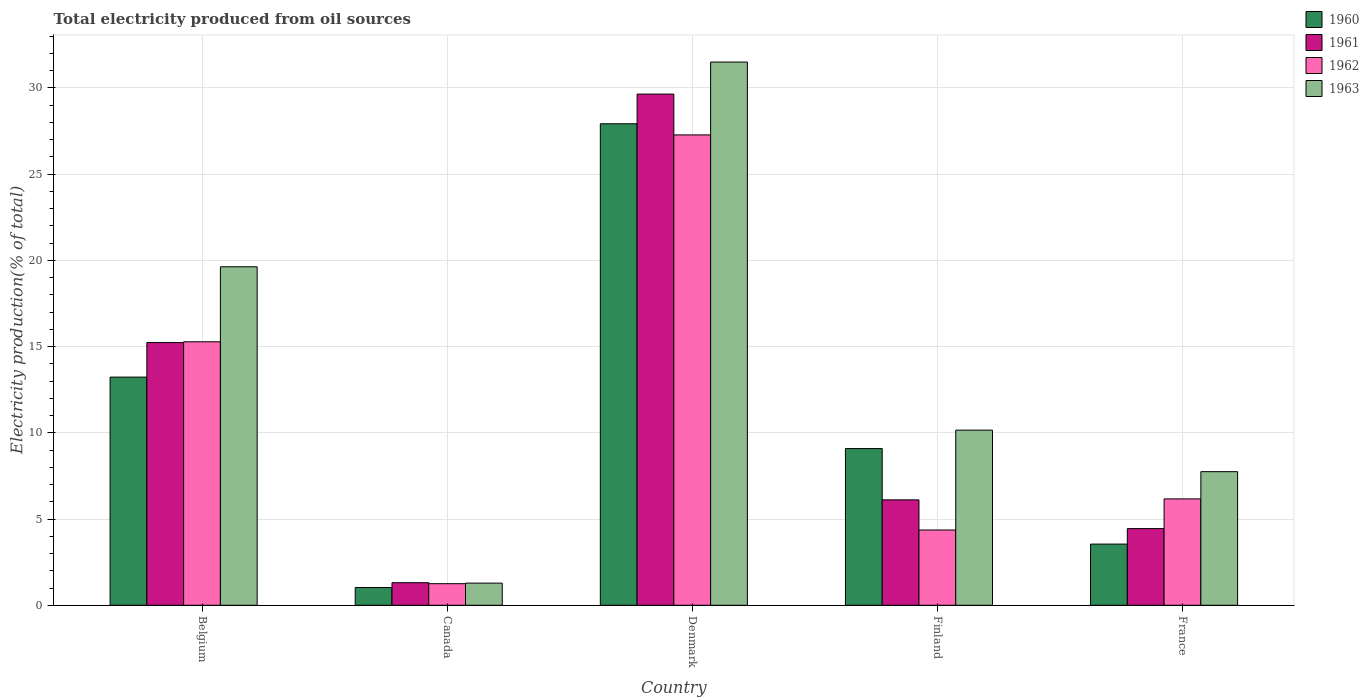How many bars are there on the 2nd tick from the left?
Offer a terse response. 4. How many bars are there on the 5th tick from the right?
Make the answer very short. 4. What is the label of the 2nd group of bars from the left?
Your answer should be compact. Canada. What is the total electricity produced in 1962 in Finland?
Your response must be concise. 4.36. Across all countries, what is the maximum total electricity produced in 1961?
Offer a very short reply. 29.65. Across all countries, what is the minimum total electricity produced in 1962?
Your response must be concise. 1.25. In which country was the total electricity produced in 1963 maximum?
Provide a short and direct response. Denmark. What is the total total electricity produced in 1963 in the graph?
Offer a very short reply. 70.32. What is the difference between the total electricity produced in 1962 in Belgium and that in France?
Offer a very short reply. 9.11. What is the difference between the total electricity produced in 1960 in France and the total electricity produced in 1962 in Finland?
Provide a short and direct response. -0.82. What is the average total electricity produced in 1963 per country?
Offer a terse response. 14.06. What is the difference between the total electricity produced of/in 1961 and total electricity produced of/in 1963 in Finland?
Your response must be concise. -4.04. In how many countries, is the total electricity produced in 1963 greater than 21 %?
Your response must be concise. 1. What is the ratio of the total electricity produced in 1963 in Denmark to that in Finland?
Offer a terse response. 3.1. Is the total electricity produced in 1961 in Canada less than that in Denmark?
Offer a very short reply. Yes. What is the difference between the highest and the second highest total electricity produced in 1961?
Offer a very short reply. 23.53. What is the difference between the highest and the lowest total electricity produced in 1960?
Give a very brief answer. 26.9. What does the 3rd bar from the left in Denmark represents?
Your answer should be very brief. 1962. What does the 3rd bar from the right in Canada represents?
Offer a very short reply. 1961. Are all the bars in the graph horizontal?
Make the answer very short. No. How many countries are there in the graph?
Keep it short and to the point. 5. What is the difference between two consecutive major ticks on the Y-axis?
Give a very brief answer. 5. Are the values on the major ticks of Y-axis written in scientific E-notation?
Provide a short and direct response. No. Does the graph contain grids?
Provide a succinct answer. Yes. How many legend labels are there?
Offer a very short reply. 4. What is the title of the graph?
Make the answer very short. Total electricity produced from oil sources. Does "1996" appear as one of the legend labels in the graph?
Your answer should be very brief. No. What is the label or title of the X-axis?
Offer a terse response. Country. What is the Electricity production(% of total) of 1960 in Belgium?
Keep it short and to the point. 13.23. What is the Electricity production(% of total) of 1961 in Belgium?
Provide a succinct answer. 15.23. What is the Electricity production(% of total) of 1962 in Belgium?
Provide a succinct answer. 15.28. What is the Electricity production(% of total) of 1963 in Belgium?
Keep it short and to the point. 19.63. What is the Electricity production(% of total) of 1960 in Canada?
Make the answer very short. 1.03. What is the Electricity production(% of total) of 1961 in Canada?
Your answer should be compact. 1.31. What is the Electricity production(% of total) in 1962 in Canada?
Offer a very short reply. 1.25. What is the Electricity production(% of total) in 1963 in Canada?
Provide a short and direct response. 1.28. What is the Electricity production(% of total) in 1960 in Denmark?
Your response must be concise. 27.92. What is the Electricity production(% of total) in 1961 in Denmark?
Offer a very short reply. 29.65. What is the Electricity production(% of total) in 1962 in Denmark?
Ensure brevity in your answer.  27.28. What is the Electricity production(% of total) in 1963 in Denmark?
Provide a short and direct response. 31.51. What is the Electricity production(% of total) of 1960 in Finland?
Your answer should be compact. 9.09. What is the Electricity production(% of total) in 1961 in Finland?
Your answer should be very brief. 6.11. What is the Electricity production(% of total) of 1962 in Finland?
Ensure brevity in your answer.  4.36. What is the Electricity production(% of total) of 1963 in Finland?
Your answer should be compact. 10.16. What is the Electricity production(% of total) in 1960 in France?
Provide a short and direct response. 3.55. What is the Electricity production(% of total) of 1961 in France?
Your answer should be compact. 4.45. What is the Electricity production(% of total) of 1962 in France?
Ensure brevity in your answer.  6.17. What is the Electricity production(% of total) of 1963 in France?
Your answer should be very brief. 7.75. Across all countries, what is the maximum Electricity production(% of total) of 1960?
Your response must be concise. 27.92. Across all countries, what is the maximum Electricity production(% of total) in 1961?
Your response must be concise. 29.65. Across all countries, what is the maximum Electricity production(% of total) of 1962?
Your response must be concise. 27.28. Across all countries, what is the maximum Electricity production(% of total) of 1963?
Ensure brevity in your answer.  31.51. Across all countries, what is the minimum Electricity production(% of total) in 1960?
Offer a terse response. 1.03. Across all countries, what is the minimum Electricity production(% of total) of 1961?
Give a very brief answer. 1.31. Across all countries, what is the minimum Electricity production(% of total) in 1962?
Provide a short and direct response. 1.25. Across all countries, what is the minimum Electricity production(% of total) in 1963?
Offer a very short reply. 1.28. What is the total Electricity production(% of total) of 1960 in the graph?
Your answer should be very brief. 54.82. What is the total Electricity production(% of total) of 1961 in the graph?
Your response must be concise. 56.75. What is the total Electricity production(% of total) of 1962 in the graph?
Provide a short and direct response. 54.34. What is the total Electricity production(% of total) of 1963 in the graph?
Give a very brief answer. 70.32. What is the difference between the Electricity production(% of total) of 1960 in Belgium and that in Canada?
Provide a short and direct response. 12.2. What is the difference between the Electricity production(% of total) of 1961 in Belgium and that in Canada?
Make the answer very short. 13.93. What is the difference between the Electricity production(% of total) of 1962 in Belgium and that in Canada?
Your answer should be very brief. 14.03. What is the difference between the Electricity production(% of total) of 1963 in Belgium and that in Canada?
Provide a succinct answer. 18.35. What is the difference between the Electricity production(% of total) in 1960 in Belgium and that in Denmark?
Your response must be concise. -14.69. What is the difference between the Electricity production(% of total) in 1961 in Belgium and that in Denmark?
Your answer should be very brief. -14.41. What is the difference between the Electricity production(% of total) in 1962 in Belgium and that in Denmark?
Give a very brief answer. -12. What is the difference between the Electricity production(% of total) of 1963 in Belgium and that in Denmark?
Your response must be concise. -11.87. What is the difference between the Electricity production(% of total) of 1960 in Belgium and that in Finland?
Ensure brevity in your answer.  4.14. What is the difference between the Electricity production(% of total) of 1961 in Belgium and that in Finland?
Your answer should be very brief. 9.12. What is the difference between the Electricity production(% of total) of 1962 in Belgium and that in Finland?
Provide a short and direct response. 10.92. What is the difference between the Electricity production(% of total) of 1963 in Belgium and that in Finland?
Give a very brief answer. 9.47. What is the difference between the Electricity production(% of total) of 1960 in Belgium and that in France?
Your response must be concise. 9.68. What is the difference between the Electricity production(% of total) in 1961 in Belgium and that in France?
Make the answer very short. 10.79. What is the difference between the Electricity production(% of total) of 1962 in Belgium and that in France?
Ensure brevity in your answer.  9.11. What is the difference between the Electricity production(% of total) of 1963 in Belgium and that in France?
Make the answer very short. 11.88. What is the difference between the Electricity production(% of total) in 1960 in Canada and that in Denmark?
Offer a very short reply. -26.9. What is the difference between the Electricity production(% of total) of 1961 in Canada and that in Denmark?
Offer a very short reply. -28.34. What is the difference between the Electricity production(% of total) in 1962 in Canada and that in Denmark?
Offer a terse response. -26.03. What is the difference between the Electricity production(% of total) of 1963 in Canada and that in Denmark?
Ensure brevity in your answer.  -30.22. What is the difference between the Electricity production(% of total) of 1960 in Canada and that in Finland?
Offer a very short reply. -8.06. What is the difference between the Electricity production(% of total) of 1961 in Canada and that in Finland?
Ensure brevity in your answer.  -4.8. What is the difference between the Electricity production(% of total) of 1962 in Canada and that in Finland?
Your answer should be very brief. -3.11. What is the difference between the Electricity production(% of total) of 1963 in Canada and that in Finland?
Give a very brief answer. -8.87. What is the difference between the Electricity production(% of total) in 1960 in Canada and that in France?
Provide a short and direct response. -2.52. What is the difference between the Electricity production(% of total) of 1961 in Canada and that in France?
Offer a terse response. -3.14. What is the difference between the Electricity production(% of total) of 1962 in Canada and that in France?
Offer a terse response. -4.92. What is the difference between the Electricity production(% of total) in 1963 in Canada and that in France?
Make the answer very short. -6.46. What is the difference between the Electricity production(% of total) of 1960 in Denmark and that in Finland?
Offer a very short reply. 18.84. What is the difference between the Electricity production(% of total) of 1961 in Denmark and that in Finland?
Your answer should be compact. 23.53. What is the difference between the Electricity production(% of total) in 1962 in Denmark and that in Finland?
Keep it short and to the point. 22.91. What is the difference between the Electricity production(% of total) of 1963 in Denmark and that in Finland?
Make the answer very short. 21.35. What is the difference between the Electricity production(% of total) in 1960 in Denmark and that in France?
Offer a very short reply. 24.38. What is the difference between the Electricity production(% of total) in 1961 in Denmark and that in France?
Provide a succinct answer. 25.2. What is the difference between the Electricity production(% of total) of 1962 in Denmark and that in France?
Keep it short and to the point. 21.11. What is the difference between the Electricity production(% of total) of 1963 in Denmark and that in France?
Provide a succinct answer. 23.76. What is the difference between the Electricity production(% of total) of 1960 in Finland and that in France?
Your answer should be very brief. 5.54. What is the difference between the Electricity production(% of total) in 1961 in Finland and that in France?
Ensure brevity in your answer.  1.67. What is the difference between the Electricity production(% of total) in 1962 in Finland and that in France?
Your response must be concise. -1.8. What is the difference between the Electricity production(% of total) of 1963 in Finland and that in France?
Give a very brief answer. 2.41. What is the difference between the Electricity production(% of total) in 1960 in Belgium and the Electricity production(% of total) in 1961 in Canada?
Ensure brevity in your answer.  11.92. What is the difference between the Electricity production(% of total) in 1960 in Belgium and the Electricity production(% of total) in 1962 in Canada?
Your answer should be very brief. 11.98. What is the difference between the Electricity production(% of total) in 1960 in Belgium and the Electricity production(% of total) in 1963 in Canada?
Offer a terse response. 11.95. What is the difference between the Electricity production(% of total) of 1961 in Belgium and the Electricity production(% of total) of 1962 in Canada?
Give a very brief answer. 13.98. What is the difference between the Electricity production(% of total) of 1961 in Belgium and the Electricity production(% of total) of 1963 in Canada?
Offer a very short reply. 13.95. What is the difference between the Electricity production(% of total) in 1962 in Belgium and the Electricity production(% of total) in 1963 in Canada?
Keep it short and to the point. 14. What is the difference between the Electricity production(% of total) in 1960 in Belgium and the Electricity production(% of total) in 1961 in Denmark?
Provide a short and direct response. -16.41. What is the difference between the Electricity production(% of total) of 1960 in Belgium and the Electricity production(% of total) of 1962 in Denmark?
Keep it short and to the point. -14.05. What is the difference between the Electricity production(% of total) in 1960 in Belgium and the Electricity production(% of total) in 1963 in Denmark?
Ensure brevity in your answer.  -18.27. What is the difference between the Electricity production(% of total) in 1961 in Belgium and the Electricity production(% of total) in 1962 in Denmark?
Your answer should be compact. -12.04. What is the difference between the Electricity production(% of total) in 1961 in Belgium and the Electricity production(% of total) in 1963 in Denmark?
Give a very brief answer. -16.27. What is the difference between the Electricity production(% of total) of 1962 in Belgium and the Electricity production(% of total) of 1963 in Denmark?
Provide a short and direct response. -16.22. What is the difference between the Electricity production(% of total) of 1960 in Belgium and the Electricity production(% of total) of 1961 in Finland?
Your answer should be very brief. 7.12. What is the difference between the Electricity production(% of total) in 1960 in Belgium and the Electricity production(% of total) in 1962 in Finland?
Offer a terse response. 8.87. What is the difference between the Electricity production(% of total) in 1960 in Belgium and the Electricity production(% of total) in 1963 in Finland?
Your response must be concise. 3.08. What is the difference between the Electricity production(% of total) in 1961 in Belgium and the Electricity production(% of total) in 1962 in Finland?
Ensure brevity in your answer.  10.87. What is the difference between the Electricity production(% of total) of 1961 in Belgium and the Electricity production(% of total) of 1963 in Finland?
Provide a short and direct response. 5.08. What is the difference between the Electricity production(% of total) of 1962 in Belgium and the Electricity production(% of total) of 1963 in Finland?
Make the answer very short. 5.12. What is the difference between the Electricity production(% of total) of 1960 in Belgium and the Electricity production(% of total) of 1961 in France?
Make the answer very short. 8.79. What is the difference between the Electricity production(% of total) in 1960 in Belgium and the Electricity production(% of total) in 1962 in France?
Your response must be concise. 7.06. What is the difference between the Electricity production(% of total) in 1960 in Belgium and the Electricity production(% of total) in 1963 in France?
Provide a short and direct response. 5.48. What is the difference between the Electricity production(% of total) in 1961 in Belgium and the Electricity production(% of total) in 1962 in France?
Make the answer very short. 9.07. What is the difference between the Electricity production(% of total) of 1961 in Belgium and the Electricity production(% of total) of 1963 in France?
Give a very brief answer. 7.49. What is the difference between the Electricity production(% of total) in 1962 in Belgium and the Electricity production(% of total) in 1963 in France?
Your answer should be very brief. 7.53. What is the difference between the Electricity production(% of total) of 1960 in Canada and the Electricity production(% of total) of 1961 in Denmark?
Provide a succinct answer. -28.62. What is the difference between the Electricity production(% of total) of 1960 in Canada and the Electricity production(% of total) of 1962 in Denmark?
Give a very brief answer. -26.25. What is the difference between the Electricity production(% of total) in 1960 in Canada and the Electricity production(% of total) in 1963 in Denmark?
Offer a very short reply. -30.48. What is the difference between the Electricity production(% of total) of 1961 in Canada and the Electricity production(% of total) of 1962 in Denmark?
Ensure brevity in your answer.  -25.97. What is the difference between the Electricity production(% of total) in 1961 in Canada and the Electricity production(% of total) in 1963 in Denmark?
Give a very brief answer. -30.2. What is the difference between the Electricity production(% of total) in 1962 in Canada and the Electricity production(% of total) in 1963 in Denmark?
Offer a very short reply. -30.25. What is the difference between the Electricity production(% of total) in 1960 in Canada and the Electricity production(% of total) in 1961 in Finland?
Give a very brief answer. -5.08. What is the difference between the Electricity production(% of total) of 1960 in Canada and the Electricity production(% of total) of 1962 in Finland?
Offer a terse response. -3.34. What is the difference between the Electricity production(% of total) in 1960 in Canada and the Electricity production(% of total) in 1963 in Finland?
Provide a short and direct response. -9.13. What is the difference between the Electricity production(% of total) of 1961 in Canada and the Electricity production(% of total) of 1962 in Finland?
Ensure brevity in your answer.  -3.06. What is the difference between the Electricity production(% of total) in 1961 in Canada and the Electricity production(% of total) in 1963 in Finland?
Provide a short and direct response. -8.85. What is the difference between the Electricity production(% of total) in 1962 in Canada and the Electricity production(% of total) in 1963 in Finland?
Keep it short and to the point. -8.91. What is the difference between the Electricity production(% of total) of 1960 in Canada and the Electricity production(% of total) of 1961 in France?
Give a very brief answer. -3.42. What is the difference between the Electricity production(% of total) in 1960 in Canada and the Electricity production(% of total) in 1962 in France?
Give a very brief answer. -5.14. What is the difference between the Electricity production(% of total) in 1960 in Canada and the Electricity production(% of total) in 1963 in France?
Your answer should be very brief. -6.72. What is the difference between the Electricity production(% of total) in 1961 in Canada and the Electricity production(% of total) in 1962 in France?
Provide a short and direct response. -4.86. What is the difference between the Electricity production(% of total) in 1961 in Canada and the Electricity production(% of total) in 1963 in France?
Provide a succinct answer. -6.44. What is the difference between the Electricity production(% of total) in 1962 in Canada and the Electricity production(% of total) in 1963 in France?
Provide a short and direct response. -6.5. What is the difference between the Electricity production(% of total) of 1960 in Denmark and the Electricity production(% of total) of 1961 in Finland?
Keep it short and to the point. 21.81. What is the difference between the Electricity production(% of total) in 1960 in Denmark and the Electricity production(% of total) in 1962 in Finland?
Keep it short and to the point. 23.56. What is the difference between the Electricity production(% of total) of 1960 in Denmark and the Electricity production(% of total) of 1963 in Finland?
Your answer should be compact. 17.77. What is the difference between the Electricity production(% of total) of 1961 in Denmark and the Electricity production(% of total) of 1962 in Finland?
Provide a succinct answer. 25.28. What is the difference between the Electricity production(% of total) in 1961 in Denmark and the Electricity production(% of total) in 1963 in Finland?
Keep it short and to the point. 19.49. What is the difference between the Electricity production(% of total) of 1962 in Denmark and the Electricity production(% of total) of 1963 in Finland?
Provide a succinct answer. 17.12. What is the difference between the Electricity production(% of total) in 1960 in Denmark and the Electricity production(% of total) in 1961 in France?
Your answer should be very brief. 23.48. What is the difference between the Electricity production(% of total) in 1960 in Denmark and the Electricity production(% of total) in 1962 in France?
Give a very brief answer. 21.75. What is the difference between the Electricity production(% of total) in 1960 in Denmark and the Electricity production(% of total) in 1963 in France?
Your answer should be very brief. 20.18. What is the difference between the Electricity production(% of total) of 1961 in Denmark and the Electricity production(% of total) of 1962 in France?
Offer a terse response. 23.48. What is the difference between the Electricity production(% of total) in 1961 in Denmark and the Electricity production(% of total) in 1963 in France?
Your answer should be very brief. 21.9. What is the difference between the Electricity production(% of total) in 1962 in Denmark and the Electricity production(% of total) in 1963 in France?
Keep it short and to the point. 19.53. What is the difference between the Electricity production(% of total) in 1960 in Finland and the Electricity production(% of total) in 1961 in France?
Keep it short and to the point. 4.64. What is the difference between the Electricity production(% of total) in 1960 in Finland and the Electricity production(% of total) in 1962 in France?
Provide a short and direct response. 2.92. What is the difference between the Electricity production(% of total) in 1960 in Finland and the Electricity production(% of total) in 1963 in France?
Keep it short and to the point. 1.34. What is the difference between the Electricity production(% of total) in 1961 in Finland and the Electricity production(% of total) in 1962 in France?
Keep it short and to the point. -0.06. What is the difference between the Electricity production(% of total) in 1961 in Finland and the Electricity production(% of total) in 1963 in France?
Offer a very short reply. -1.64. What is the difference between the Electricity production(% of total) in 1962 in Finland and the Electricity production(% of total) in 1963 in France?
Your answer should be very brief. -3.38. What is the average Electricity production(% of total) in 1960 per country?
Keep it short and to the point. 10.96. What is the average Electricity production(% of total) of 1961 per country?
Your response must be concise. 11.35. What is the average Electricity production(% of total) in 1962 per country?
Offer a terse response. 10.87. What is the average Electricity production(% of total) of 1963 per country?
Provide a succinct answer. 14.06. What is the difference between the Electricity production(% of total) of 1960 and Electricity production(% of total) of 1961 in Belgium?
Your answer should be compact. -2. What is the difference between the Electricity production(% of total) of 1960 and Electricity production(% of total) of 1962 in Belgium?
Provide a succinct answer. -2.05. What is the difference between the Electricity production(% of total) in 1960 and Electricity production(% of total) in 1963 in Belgium?
Keep it short and to the point. -6.4. What is the difference between the Electricity production(% of total) in 1961 and Electricity production(% of total) in 1962 in Belgium?
Provide a short and direct response. -0.05. What is the difference between the Electricity production(% of total) in 1961 and Electricity production(% of total) in 1963 in Belgium?
Provide a short and direct response. -4.4. What is the difference between the Electricity production(% of total) of 1962 and Electricity production(% of total) of 1963 in Belgium?
Ensure brevity in your answer.  -4.35. What is the difference between the Electricity production(% of total) of 1960 and Electricity production(% of total) of 1961 in Canada?
Your answer should be very brief. -0.28. What is the difference between the Electricity production(% of total) of 1960 and Electricity production(% of total) of 1962 in Canada?
Ensure brevity in your answer.  -0.22. What is the difference between the Electricity production(% of total) of 1960 and Electricity production(% of total) of 1963 in Canada?
Provide a short and direct response. -0.26. What is the difference between the Electricity production(% of total) in 1961 and Electricity production(% of total) in 1962 in Canada?
Give a very brief answer. 0.06. What is the difference between the Electricity production(% of total) of 1961 and Electricity production(% of total) of 1963 in Canada?
Give a very brief answer. 0.03. What is the difference between the Electricity production(% of total) in 1962 and Electricity production(% of total) in 1963 in Canada?
Your answer should be very brief. -0.03. What is the difference between the Electricity production(% of total) of 1960 and Electricity production(% of total) of 1961 in Denmark?
Your answer should be very brief. -1.72. What is the difference between the Electricity production(% of total) of 1960 and Electricity production(% of total) of 1962 in Denmark?
Your response must be concise. 0.65. What is the difference between the Electricity production(% of total) in 1960 and Electricity production(% of total) in 1963 in Denmark?
Offer a very short reply. -3.58. What is the difference between the Electricity production(% of total) in 1961 and Electricity production(% of total) in 1962 in Denmark?
Offer a terse response. 2.37. What is the difference between the Electricity production(% of total) of 1961 and Electricity production(% of total) of 1963 in Denmark?
Give a very brief answer. -1.86. What is the difference between the Electricity production(% of total) in 1962 and Electricity production(% of total) in 1963 in Denmark?
Offer a terse response. -4.23. What is the difference between the Electricity production(% of total) in 1960 and Electricity production(% of total) in 1961 in Finland?
Give a very brief answer. 2.98. What is the difference between the Electricity production(% of total) of 1960 and Electricity production(% of total) of 1962 in Finland?
Your answer should be compact. 4.72. What is the difference between the Electricity production(% of total) in 1960 and Electricity production(% of total) in 1963 in Finland?
Your answer should be very brief. -1.07. What is the difference between the Electricity production(% of total) in 1961 and Electricity production(% of total) in 1962 in Finland?
Provide a succinct answer. 1.75. What is the difference between the Electricity production(% of total) in 1961 and Electricity production(% of total) in 1963 in Finland?
Make the answer very short. -4.04. What is the difference between the Electricity production(% of total) in 1962 and Electricity production(% of total) in 1963 in Finland?
Offer a very short reply. -5.79. What is the difference between the Electricity production(% of total) in 1960 and Electricity production(% of total) in 1961 in France?
Provide a short and direct response. -0.9. What is the difference between the Electricity production(% of total) in 1960 and Electricity production(% of total) in 1962 in France?
Provide a succinct answer. -2.62. What is the difference between the Electricity production(% of total) of 1960 and Electricity production(% of total) of 1963 in France?
Offer a terse response. -4.2. What is the difference between the Electricity production(% of total) in 1961 and Electricity production(% of total) in 1962 in France?
Offer a terse response. -1.72. What is the difference between the Electricity production(% of total) in 1961 and Electricity production(% of total) in 1963 in France?
Offer a very short reply. -3.3. What is the difference between the Electricity production(% of total) in 1962 and Electricity production(% of total) in 1963 in France?
Provide a short and direct response. -1.58. What is the ratio of the Electricity production(% of total) in 1960 in Belgium to that in Canada?
Ensure brevity in your answer.  12.86. What is the ratio of the Electricity production(% of total) of 1961 in Belgium to that in Canada?
Your answer should be compact. 11.64. What is the ratio of the Electricity production(% of total) of 1962 in Belgium to that in Canada?
Ensure brevity in your answer.  12.21. What is the ratio of the Electricity production(% of total) of 1963 in Belgium to that in Canada?
Provide a short and direct response. 15.29. What is the ratio of the Electricity production(% of total) in 1960 in Belgium to that in Denmark?
Your response must be concise. 0.47. What is the ratio of the Electricity production(% of total) of 1961 in Belgium to that in Denmark?
Provide a succinct answer. 0.51. What is the ratio of the Electricity production(% of total) in 1962 in Belgium to that in Denmark?
Your answer should be compact. 0.56. What is the ratio of the Electricity production(% of total) of 1963 in Belgium to that in Denmark?
Make the answer very short. 0.62. What is the ratio of the Electricity production(% of total) of 1960 in Belgium to that in Finland?
Your answer should be compact. 1.46. What is the ratio of the Electricity production(% of total) in 1961 in Belgium to that in Finland?
Your response must be concise. 2.49. What is the ratio of the Electricity production(% of total) of 1962 in Belgium to that in Finland?
Your response must be concise. 3.5. What is the ratio of the Electricity production(% of total) of 1963 in Belgium to that in Finland?
Keep it short and to the point. 1.93. What is the ratio of the Electricity production(% of total) in 1960 in Belgium to that in France?
Your answer should be compact. 3.73. What is the ratio of the Electricity production(% of total) of 1961 in Belgium to that in France?
Give a very brief answer. 3.43. What is the ratio of the Electricity production(% of total) in 1962 in Belgium to that in France?
Your response must be concise. 2.48. What is the ratio of the Electricity production(% of total) in 1963 in Belgium to that in France?
Provide a succinct answer. 2.53. What is the ratio of the Electricity production(% of total) of 1960 in Canada to that in Denmark?
Give a very brief answer. 0.04. What is the ratio of the Electricity production(% of total) of 1961 in Canada to that in Denmark?
Provide a short and direct response. 0.04. What is the ratio of the Electricity production(% of total) in 1962 in Canada to that in Denmark?
Your answer should be compact. 0.05. What is the ratio of the Electricity production(% of total) of 1963 in Canada to that in Denmark?
Offer a terse response. 0.04. What is the ratio of the Electricity production(% of total) of 1960 in Canada to that in Finland?
Offer a terse response. 0.11. What is the ratio of the Electricity production(% of total) in 1961 in Canada to that in Finland?
Your response must be concise. 0.21. What is the ratio of the Electricity production(% of total) in 1962 in Canada to that in Finland?
Give a very brief answer. 0.29. What is the ratio of the Electricity production(% of total) of 1963 in Canada to that in Finland?
Offer a very short reply. 0.13. What is the ratio of the Electricity production(% of total) of 1960 in Canada to that in France?
Give a very brief answer. 0.29. What is the ratio of the Electricity production(% of total) in 1961 in Canada to that in France?
Your answer should be very brief. 0.29. What is the ratio of the Electricity production(% of total) in 1962 in Canada to that in France?
Provide a succinct answer. 0.2. What is the ratio of the Electricity production(% of total) in 1963 in Canada to that in France?
Offer a very short reply. 0.17. What is the ratio of the Electricity production(% of total) of 1960 in Denmark to that in Finland?
Your answer should be very brief. 3.07. What is the ratio of the Electricity production(% of total) in 1961 in Denmark to that in Finland?
Offer a terse response. 4.85. What is the ratio of the Electricity production(% of total) of 1962 in Denmark to that in Finland?
Your response must be concise. 6.25. What is the ratio of the Electricity production(% of total) in 1963 in Denmark to that in Finland?
Your response must be concise. 3.1. What is the ratio of the Electricity production(% of total) of 1960 in Denmark to that in France?
Provide a short and direct response. 7.87. What is the ratio of the Electricity production(% of total) in 1961 in Denmark to that in France?
Your answer should be very brief. 6.67. What is the ratio of the Electricity production(% of total) of 1962 in Denmark to that in France?
Your answer should be compact. 4.42. What is the ratio of the Electricity production(% of total) in 1963 in Denmark to that in France?
Make the answer very short. 4.07. What is the ratio of the Electricity production(% of total) in 1960 in Finland to that in France?
Provide a short and direct response. 2.56. What is the ratio of the Electricity production(% of total) in 1961 in Finland to that in France?
Your answer should be very brief. 1.37. What is the ratio of the Electricity production(% of total) of 1962 in Finland to that in France?
Ensure brevity in your answer.  0.71. What is the ratio of the Electricity production(% of total) of 1963 in Finland to that in France?
Give a very brief answer. 1.31. What is the difference between the highest and the second highest Electricity production(% of total) of 1960?
Your answer should be compact. 14.69. What is the difference between the highest and the second highest Electricity production(% of total) of 1961?
Your answer should be very brief. 14.41. What is the difference between the highest and the second highest Electricity production(% of total) of 1962?
Give a very brief answer. 12. What is the difference between the highest and the second highest Electricity production(% of total) of 1963?
Your answer should be very brief. 11.87. What is the difference between the highest and the lowest Electricity production(% of total) of 1960?
Provide a short and direct response. 26.9. What is the difference between the highest and the lowest Electricity production(% of total) in 1961?
Provide a succinct answer. 28.34. What is the difference between the highest and the lowest Electricity production(% of total) in 1962?
Give a very brief answer. 26.03. What is the difference between the highest and the lowest Electricity production(% of total) in 1963?
Your answer should be very brief. 30.22. 